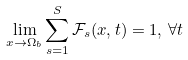Convert formula to latex. <formula><loc_0><loc_0><loc_500><loc_500>\lim _ { x \rightarrow \Omega _ { b } } \sum _ { s = 1 } ^ { S } \mathcal { F } _ { s } ( x , t ) = 1 , \, \forall t</formula> 